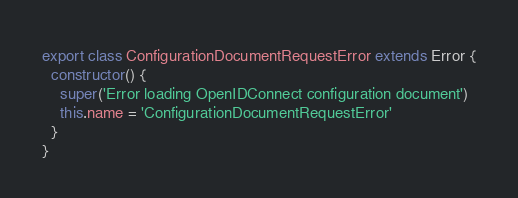<code> <loc_0><loc_0><loc_500><loc_500><_TypeScript_>export class ConfigurationDocumentRequestError extends Error {
  constructor() {
    super('Error loading OpenIDConnect configuration document')
    this.name = 'ConfigurationDocumentRequestError'
  }
}
</code> 